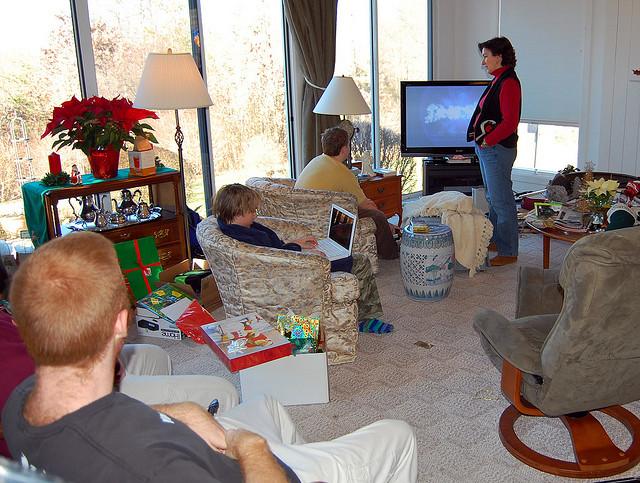What kind of flowers are near the window?
Keep it brief. Poinsettia. Where is the rug?
Concise answer only. Floor. Are there presents on the floor?
Answer briefly. Yes. How many people in this picture?
Answer briefly. 4. 